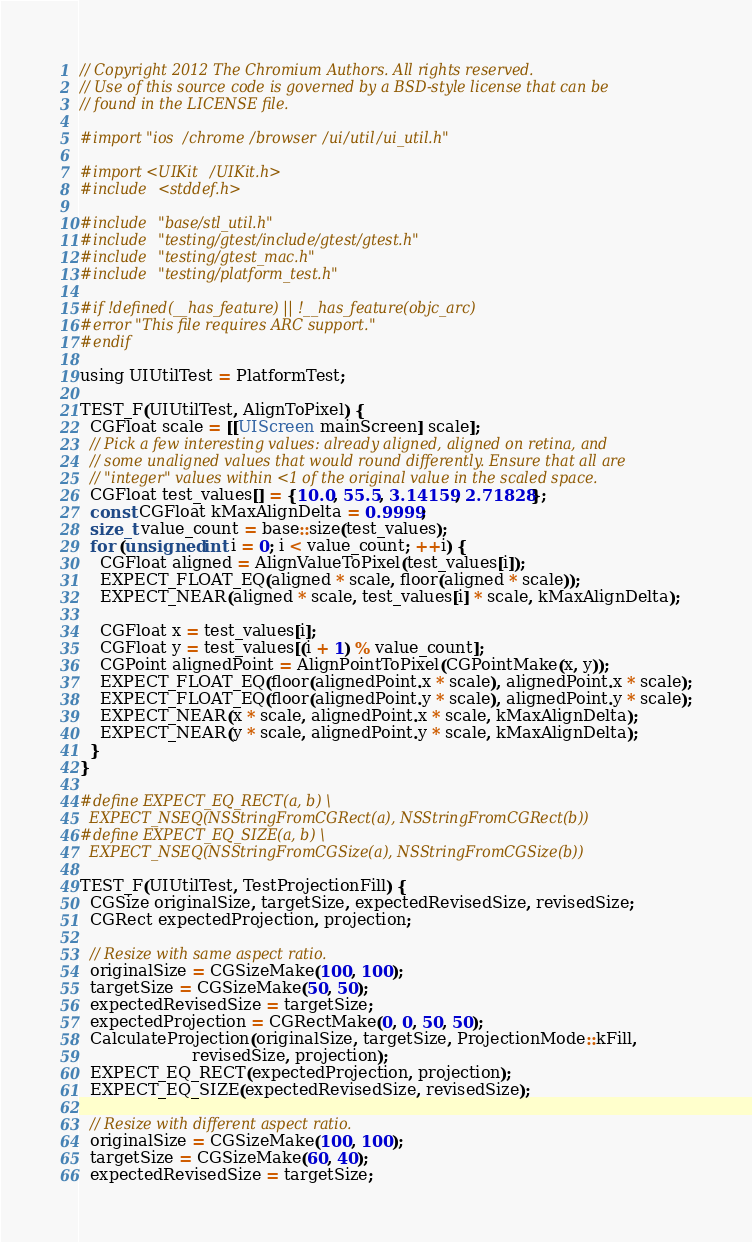<code> <loc_0><loc_0><loc_500><loc_500><_ObjectiveC_>// Copyright 2012 The Chromium Authors. All rights reserved.
// Use of this source code is governed by a BSD-style license that can be
// found in the LICENSE file.

#import "ios/chrome/browser/ui/util/ui_util.h"

#import <UIKit/UIKit.h>
#include <stddef.h>

#include "base/stl_util.h"
#include "testing/gtest/include/gtest/gtest.h"
#include "testing/gtest_mac.h"
#include "testing/platform_test.h"

#if !defined(__has_feature) || !__has_feature(objc_arc)
#error "This file requires ARC support."
#endif

using UIUtilTest = PlatformTest;

TEST_F(UIUtilTest, AlignToPixel) {
  CGFloat scale = [[UIScreen mainScreen] scale];
  // Pick a few interesting values: already aligned, aligned on retina, and
  // some unaligned values that would round differently. Ensure that all are
  // "integer" values within <1 of the original value in the scaled space.
  CGFloat test_values[] = {10.0, 55.5, 3.14159, 2.71828};
  const CGFloat kMaxAlignDelta = 0.9999;
  size_t value_count = base::size(test_values);
  for (unsigned int i = 0; i < value_count; ++i) {
    CGFloat aligned = AlignValueToPixel(test_values[i]);
    EXPECT_FLOAT_EQ(aligned * scale, floor(aligned * scale));
    EXPECT_NEAR(aligned * scale, test_values[i] * scale, kMaxAlignDelta);

    CGFloat x = test_values[i];
    CGFloat y = test_values[(i + 1) % value_count];
    CGPoint alignedPoint = AlignPointToPixel(CGPointMake(x, y));
    EXPECT_FLOAT_EQ(floor(alignedPoint.x * scale), alignedPoint.x * scale);
    EXPECT_FLOAT_EQ(floor(alignedPoint.y * scale), alignedPoint.y * scale);
    EXPECT_NEAR(x * scale, alignedPoint.x * scale, kMaxAlignDelta);
    EXPECT_NEAR(y * scale, alignedPoint.y * scale, kMaxAlignDelta);
  }
}

#define EXPECT_EQ_RECT(a, b) \
  EXPECT_NSEQ(NSStringFromCGRect(a), NSStringFromCGRect(b))
#define EXPECT_EQ_SIZE(a, b) \
  EXPECT_NSEQ(NSStringFromCGSize(a), NSStringFromCGSize(b))

TEST_F(UIUtilTest, TestProjectionFill) {
  CGSize originalSize, targetSize, expectedRevisedSize, revisedSize;
  CGRect expectedProjection, projection;

  // Resize with same aspect ratio.
  originalSize = CGSizeMake(100, 100);
  targetSize = CGSizeMake(50, 50);
  expectedRevisedSize = targetSize;
  expectedProjection = CGRectMake(0, 0, 50, 50);
  CalculateProjection(originalSize, targetSize, ProjectionMode::kFill,
                      revisedSize, projection);
  EXPECT_EQ_RECT(expectedProjection, projection);
  EXPECT_EQ_SIZE(expectedRevisedSize, revisedSize);

  // Resize with different aspect ratio.
  originalSize = CGSizeMake(100, 100);
  targetSize = CGSizeMake(60, 40);
  expectedRevisedSize = targetSize;</code> 